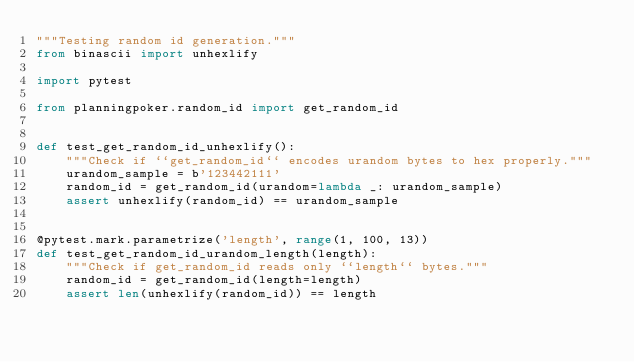Convert code to text. <code><loc_0><loc_0><loc_500><loc_500><_Python_>"""Testing random id generation."""
from binascii import unhexlify

import pytest

from planningpoker.random_id import get_random_id


def test_get_random_id_unhexlify():
    """Check if ``get_random_id`` encodes urandom bytes to hex properly."""
    urandom_sample = b'123442111'
    random_id = get_random_id(urandom=lambda _: urandom_sample)
    assert unhexlify(random_id) == urandom_sample


@pytest.mark.parametrize('length', range(1, 100, 13))
def test_get_random_id_urandom_length(length):
    """Check if get_random_id reads only ``length`` bytes."""
    random_id = get_random_id(length=length)
    assert len(unhexlify(random_id)) == length
</code> 